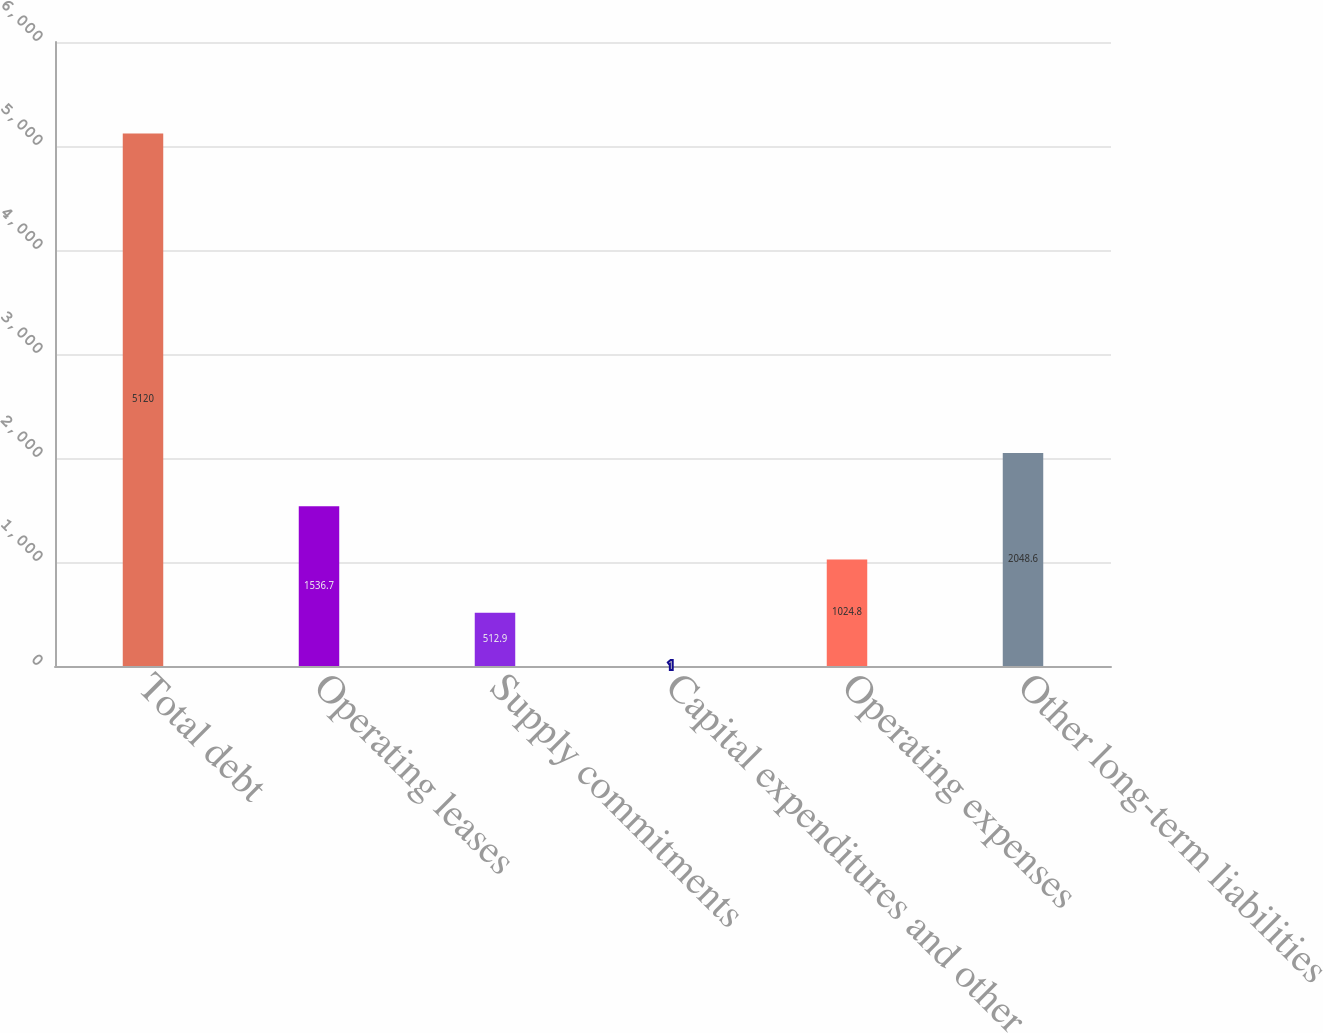Convert chart. <chart><loc_0><loc_0><loc_500><loc_500><bar_chart><fcel>Total debt<fcel>Operating leases<fcel>Supply commitments<fcel>Capital expenditures and other<fcel>Operating expenses<fcel>Other long-term liabilities<nl><fcel>5120<fcel>1536.7<fcel>512.9<fcel>1<fcel>1024.8<fcel>2048.6<nl></chart> 